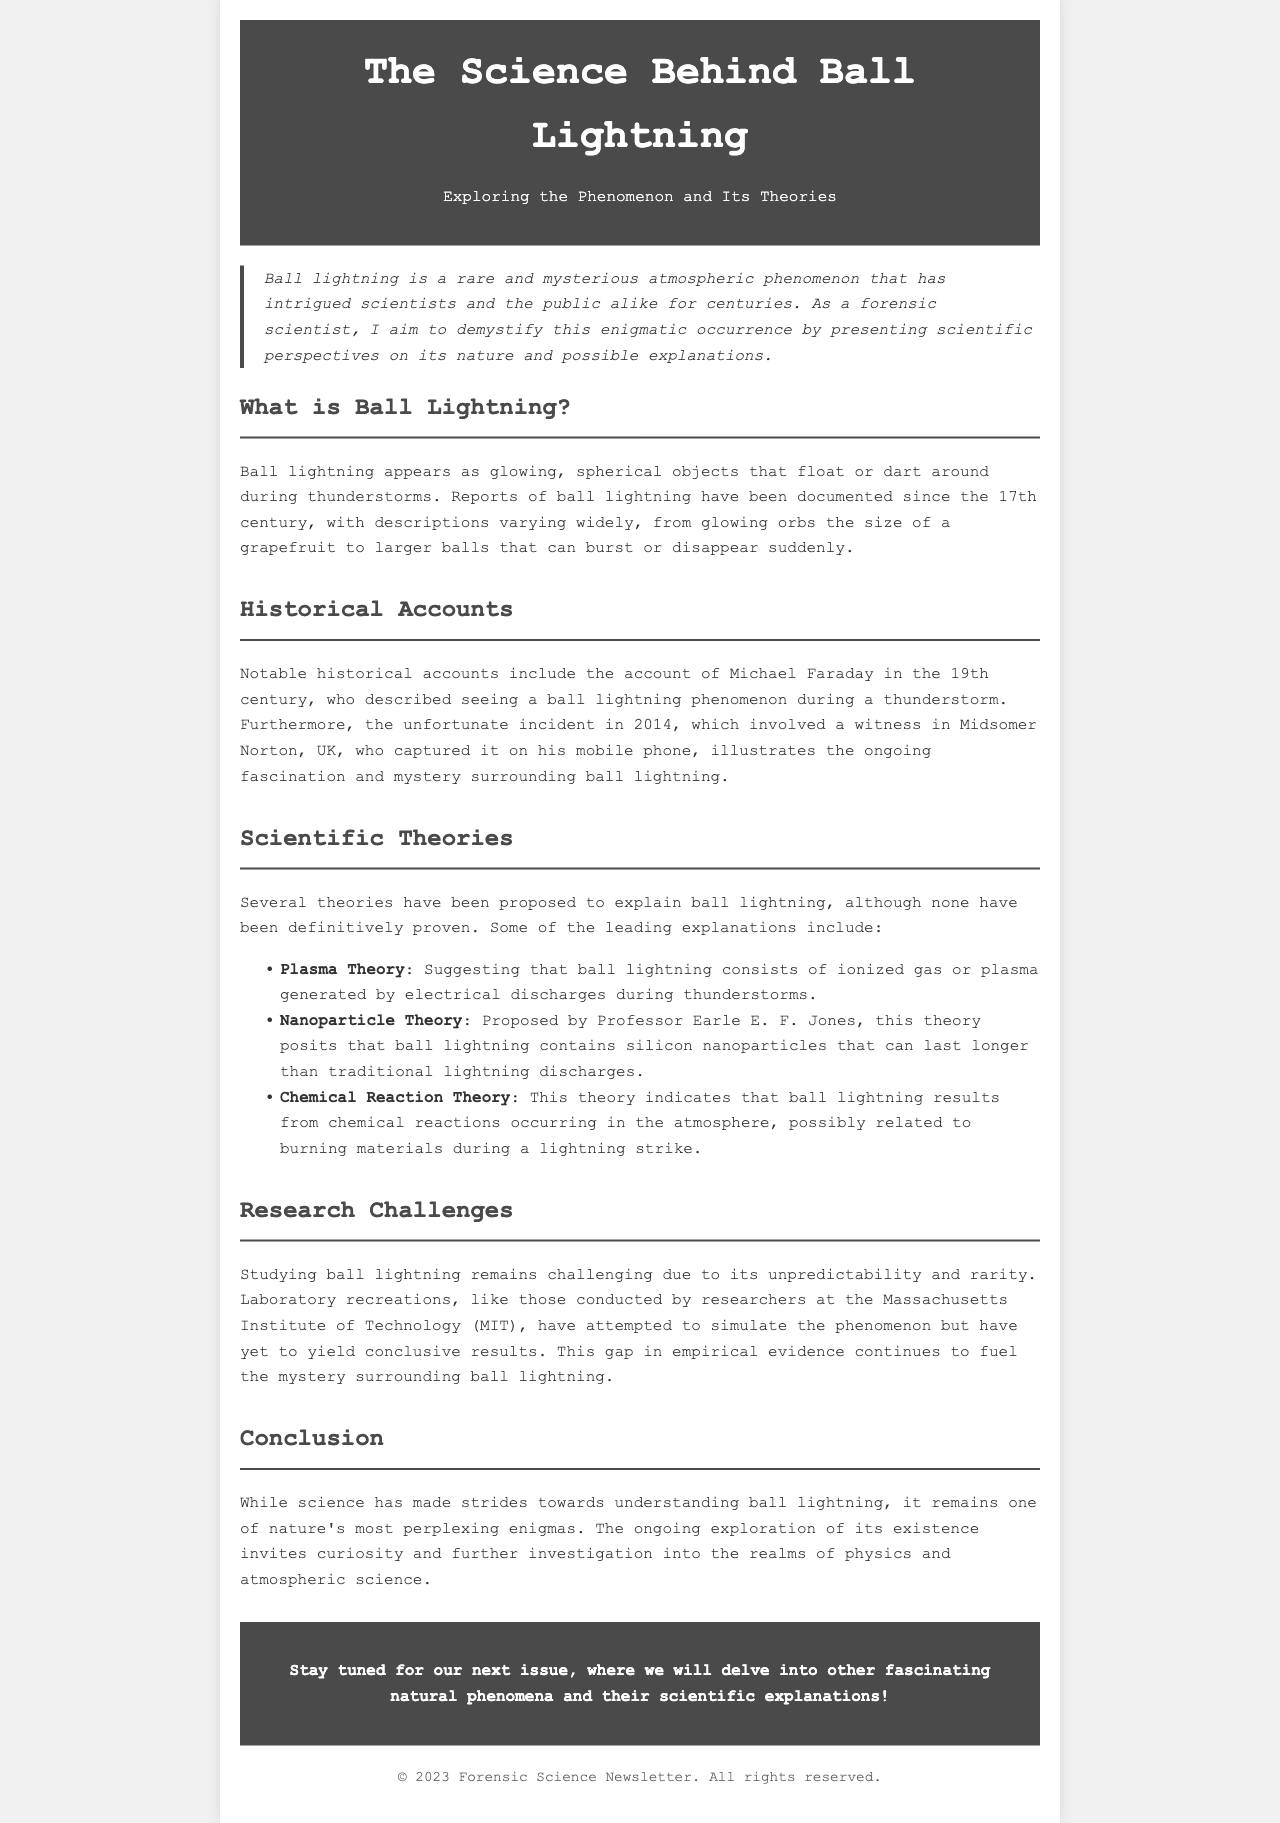What is ball lightning? Ball lightning is described as glowing, spherical objects that float or dart around during thunderstorms.
Answer: Glowing, spherical objects Who first documented ball lightning in the 19th century? Michael Faraday is noted for describing ball lightning during a thunderstorm in the 19th century.
Answer: Michael Faraday What incident in 2014 involved ball lightning? A witness in Midsomer Norton, UK, captured the phenomenon on his mobile phone.
Answer: Midsomer Norton, UK What does the plasma theory suggest about ball lightning? The plasma theory suggests that ball lightning consists of ionized gas or plasma generated by electrical discharges during thunderstorms.
Answer: Ionized gas or plasma Which organization attempted to simulate ball lightning? Researchers at the Massachusetts Institute of Technology (MIT) attempted to simulate ball lightning.
Answer: Massachusetts Institute of Technology (MIT) What phenomenon will be covered in the next issue of the newsletter? The next issue will delve into other fascinating natural phenomena and their scientific explanations.
Answer: Other fascinating natural phenomena 